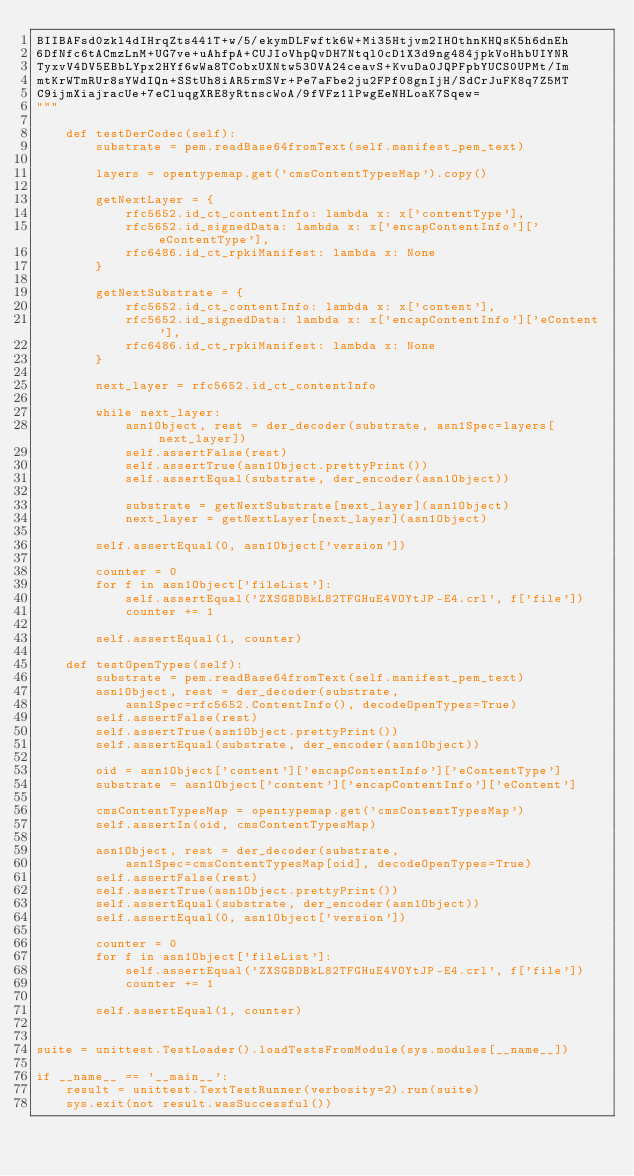Convert code to text. <code><loc_0><loc_0><loc_500><loc_500><_Python_>BIIBAFsd0zkl4dIHrqZts441T+w/5/ekymDLFwftk6W+Mi35Htjvm2IHOthnKHQsK5h6dnEh
6DfNfc6tACmzLnM+UG7ve+uAhfpA+CUJIoVhpQvDH7Ntql0cD1X3d9ng484jpkVoHhbUIYNR
TyxvV4DV5EBbLYpx2HYf6wWa8TCobxUXNtw53OVA24ceavS+KvuDa0JQPFpbYUCS0UPMt/Im
mtKrWTmRUr8sYWdIQn+SStUh8iAR5rmSVr+Pe7aFbe2ju2FPf08gnIjH/SdCrJuFK8q7Z5MT
C9ijmXiajracUe+7eCluqgXRE8yRtnscWoA/9fVFz1lPwgEeNHLoaK7Sqew=
"""

    def testDerCodec(self):
        substrate = pem.readBase64fromText(self.manifest_pem_text)

        layers = opentypemap.get('cmsContentTypesMap').copy()

        getNextLayer = {
            rfc5652.id_ct_contentInfo: lambda x: x['contentType'],
            rfc5652.id_signedData: lambda x: x['encapContentInfo']['eContentType'],
            rfc6486.id_ct_rpkiManifest: lambda x: None
        }

        getNextSubstrate = {
            rfc5652.id_ct_contentInfo: lambda x: x['content'],
            rfc5652.id_signedData: lambda x: x['encapContentInfo']['eContent'],
            rfc6486.id_ct_rpkiManifest: lambda x: None
        }

        next_layer = rfc5652.id_ct_contentInfo

        while next_layer:
            asn1Object, rest = der_decoder(substrate, asn1Spec=layers[next_layer])
            self.assertFalse(rest)
            self.assertTrue(asn1Object.prettyPrint())
            self.assertEqual(substrate, der_encoder(asn1Object))

            substrate = getNextSubstrate[next_layer](asn1Object)
            next_layer = getNextLayer[next_layer](asn1Object)

        self.assertEqual(0, asn1Object['version'])

        counter = 0
        for f in asn1Object['fileList']:
            self.assertEqual('ZXSGBDBkL82TFGHuE4VOYtJP-E4.crl', f['file'])
            counter += 1
    
        self.assertEqual(1, counter)

    def testOpenTypes(self):
        substrate = pem.readBase64fromText(self.manifest_pem_text)
        asn1Object, rest = der_decoder(substrate,
            asn1Spec=rfc5652.ContentInfo(), decodeOpenTypes=True)
        self.assertFalse(rest)
        self.assertTrue(asn1Object.prettyPrint())
        self.assertEqual(substrate, der_encoder(asn1Object))

        oid = asn1Object['content']['encapContentInfo']['eContentType']
        substrate = asn1Object['content']['encapContentInfo']['eContent']

        cmsContentTypesMap = opentypemap.get('cmsContentTypesMap')
        self.assertIn(oid, cmsContentTypesMap)

        asn1Object, rest = der_decoder(substrate,
            asn1Spec=cmsContentTypesMap[oid], decodeOpenTypes=True)
        self.assertFalse(rest)
        self.assertTrue(asn1Object.prettyPrint())
        self.assertEqual(substrate, der_encoder(asn1Object))
        self.assertEqual(0, asn1Object['version'])

        counter = 0
        for f in asn1Object['fileList']:
            self.assertEqual('ZXSGBDBkL82TFGHuE4VOYtJP-E4.crl', f['file'])
            counter += 1
    
        self.assertEqual(1, counter)


suite = unittest.TestLoader().loadTestsFromModule(sys.modules[__name__])

if __name__ == '__main__':
    result = unittest.TextTestRunner(verbosity=2).run(suite)
    sys.exit(not result.wasSuccessful())
</code> 